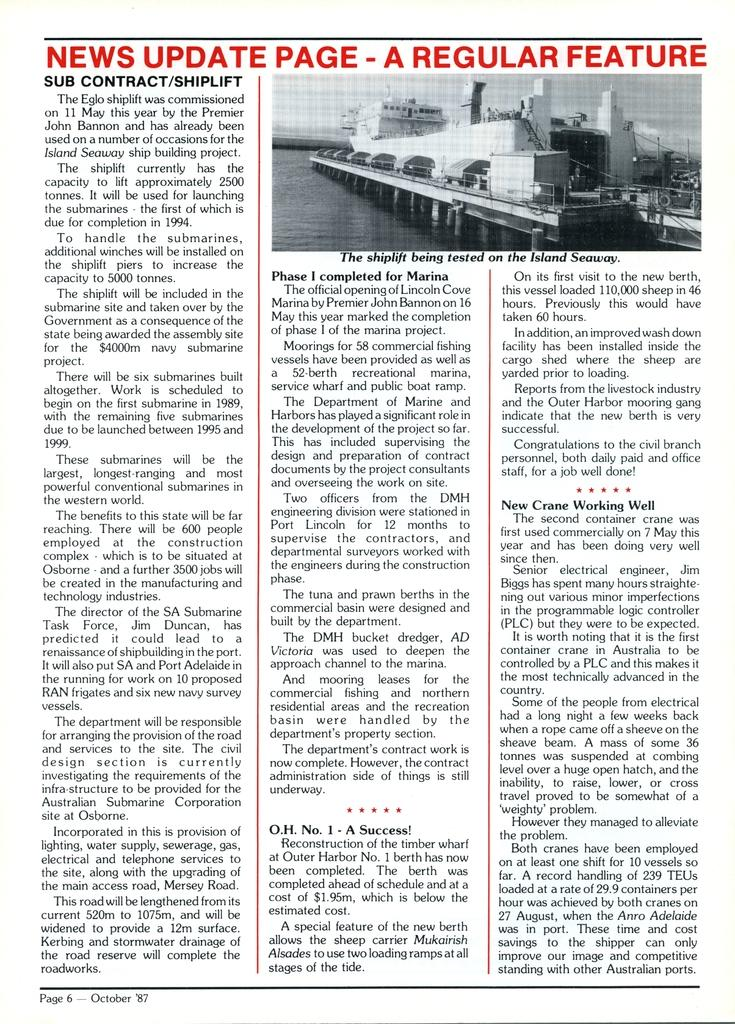What is the main object in the image? There is a magazine in the image. What is depicted on the cover of the magazine? The magazine has an image of a ship in the water. Is there any text or information related to the ship image? Yes, there is information under the image of the ship. How many girls are playing with the unit in the image? There are no girls or units present in the image; it features a magazine with a ship image and related information. 